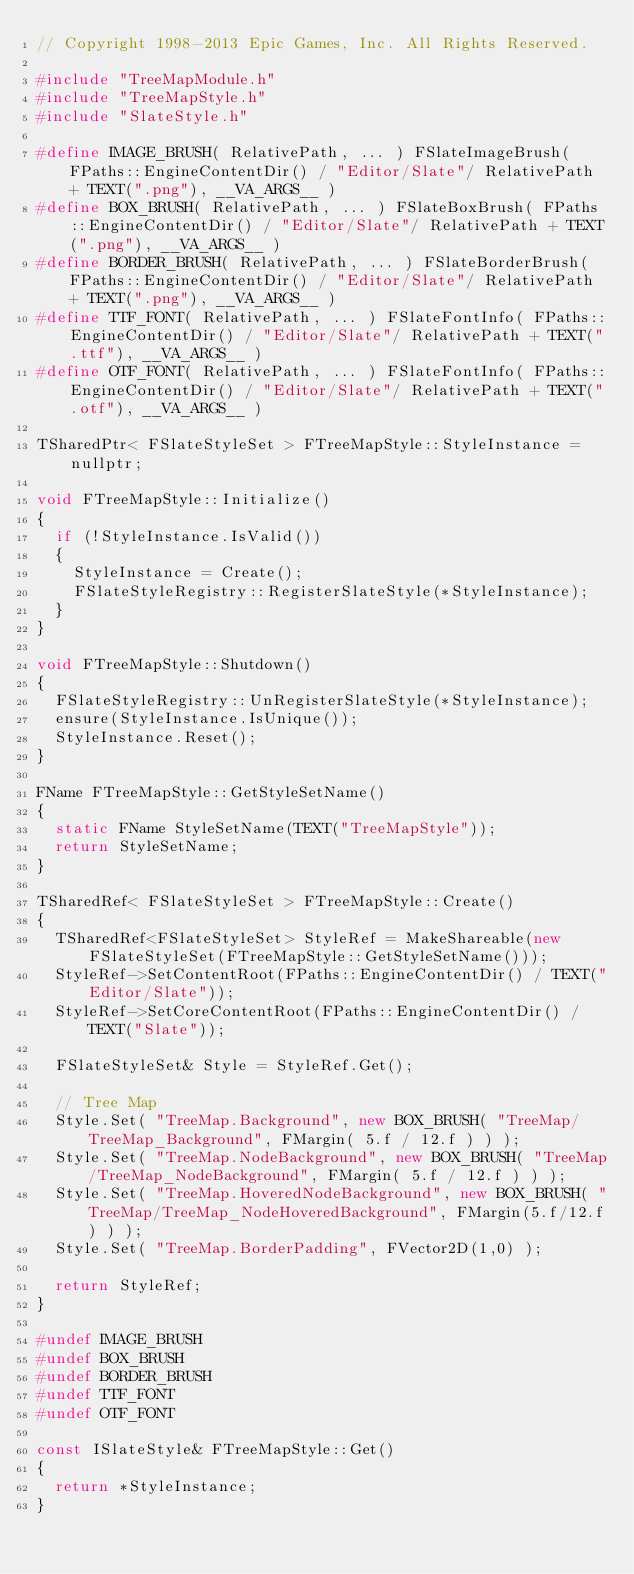<code> <loc_0><loc_0><loc_500><loc_500><_C++_>// Copyright 1998-2013 Epic Games, Inc. All Rights Reserved.

#include "TreeMapModule.h"
#include "TreeMapStyle.h"
#include "SlateStyle.h"

#define IMAGE_BRUSH( RelativePath, ... ) FSlateImageBrush( FPaths::EngineContentDir() / "Editor/Slate"/ RelativePath + TEXT(".png"), __VA_ARGS__ )
#define BOX_BRUSH( RelativePath, ... ) FSlateBoxBrush( FPaths::EngineContentDir() / "Editor/Slate"/ RelativePath + TEXT(".png"), __VA_ARGS__ )
#define BORDER_BRUSH( RelativePath, ... ) FSlateBorderBrush( FPaths::EngineContentDir() / "Editor/Slate"/ RelativePath + TEXT(".png"), __VA_ARGS__ )
#define TTF_FONT( RelativePath, ... ) FSlateFontInfo( FPaths::EngineContentDir() / "Editor/Slate"/ RelativePath + TEXT(".ttf"), __VA_ARGS__ )
#define OTF_FONT( RelativePath, ... ) FSlateFontInfo( FPaths::EngineContentDir() / "Editor/Slate"/ RelativePath + TEXT(".otf"), __VA_ARGS__ )

TSharedPtr< FSlateStyleSet > FTreeMapStyle::StyleInstance = nullptr;

void FTreeMapStyle::Initialize()
{
	if (!StyleInstance.IsValid())
	{
		StyleInstance = Create();
		FSlateStyleRegistry::RegisterSlateStyle(*StyleInstance);
	}
}

void FTreeMapStyle::Shutdown()
{
	FSlateStyleRegistry::UnRegisterSlateStyle(*StyleInstance);
	ensure(StyleInstance.IsUnique());
	StyleInstance.Reset();
}

FName FTreeMapStyle::GetStyleSetName()
{
	static FName StyleSetName(TEXT("TreeMapStyle"));
	return StyleSetName;
}

TSharedRef< FSlateStyleSet > FTreeMapStyle::Create()
{
	TSharedRef<FSlateStyleSet> StyleRef = MakeShareable(new FSlateStyleSet(FTreeMapStyle::GetStyleSetName()));
	StyleRef->SetContentRoot(FPaths::EngineContentDir() / TEXT("Editor/Slate"));
	StyleRef->SetCoreContentRoot(FPaths::EngineContentDir() / TEXT("Slate"));

	FSlateStyleSet& Style = StyleRef.Get();

	// Tree Map
	Style.Set( "TreeMap.Background", new BOX_BRUSH( "TreeMap/TreeMap_Background", FMargin( 5.f / 12.f ) ) );
	Style.Set( "TreeMap.NodeBackground", new BOX_BRUSH( "TreeMap/TreeMap_NodeBackground", FMargin( 5.f / 12.f ) ) );
	Style.Set( "TreeMap.HoveredNodeBackground", new BOX_BRUSH( "TreeMap/TreeMap_NodeHoveredBackground", FMargin(5.f/12.f) ) );
	Style.Set( "TreeMap.BorderPadding", FVector2D(1,0) );

	return StyleRef;
}

#undef IMAGE_BRUSH
#undef BOX_BRUSH
#undef BORDER_BRUSH
#undef TTF_FONT
#undef OTF_FONT

const ISlateStyle& FTreeMapStyle::Get()
{
	return *StyleInstance;
}
</code> 